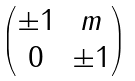<formula> <loc_0><loc_0><loc_500><loc_500>\begin{pmatrix} \pm 1 & m \\ 0 & \pm 1 \end{pmatrix}</formula> 